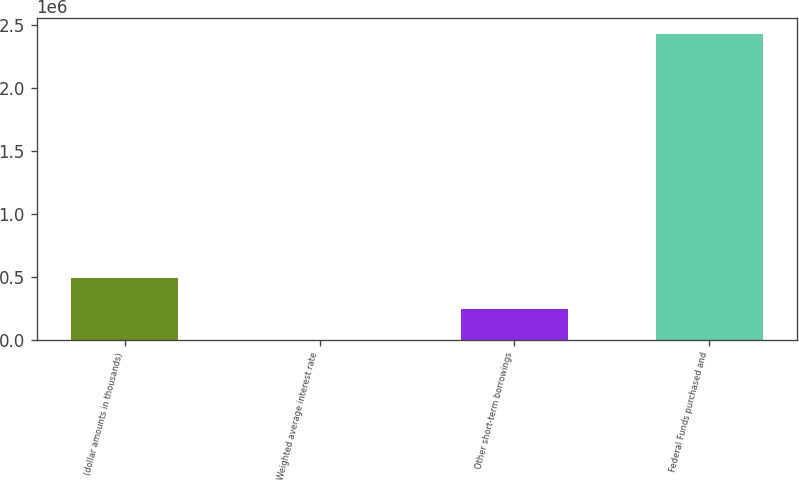Convert chart to OTSL. <chart><loc_0><loc_0><loc_500><loc_500><bar_chart><fcel>(dollar amounts in thousands)<fcel>Weighted average interest rate<fcel>Other short-term borrowings<fcel>Federal Funds purchased and<nl><fcel>486199<fcel>0.17<fcel>243099<fcel>2.43099e+06<nl></chart> 